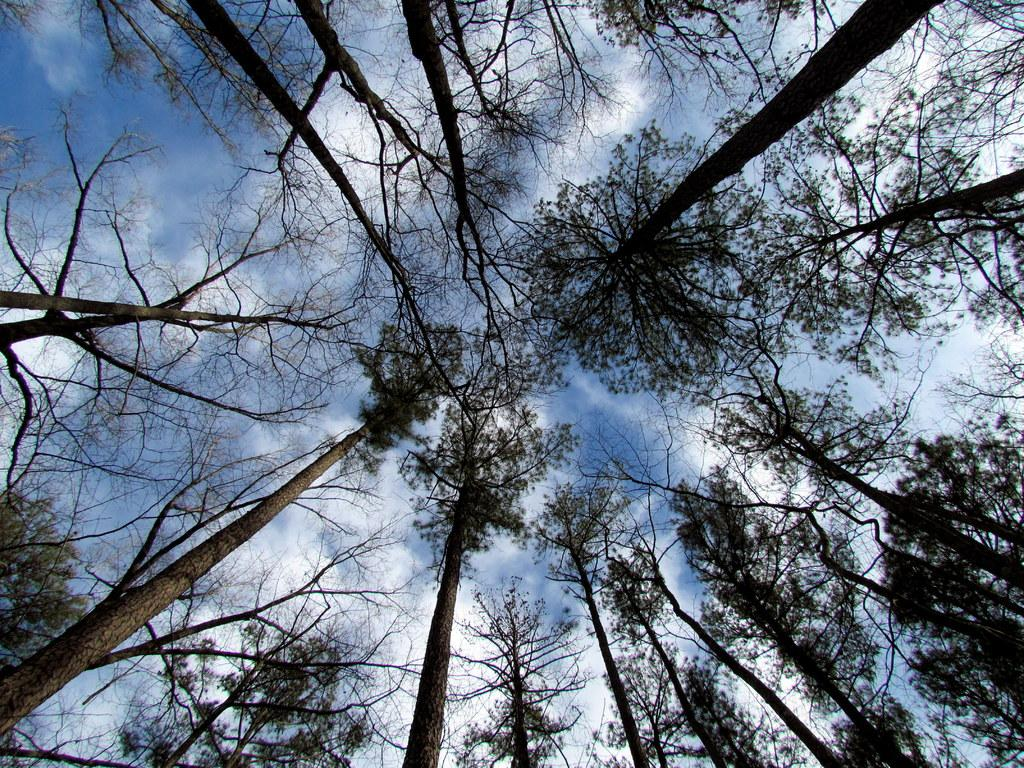Where was the image taken from? The image was taken from outside the city. What can be seen in the image besides the city? There are trees in the image. What is visible in the background of the image? The sky is visible in the background of the image. How would you describe the weather in the image? The sky is cloudy, which suggests a partly cloudy or overcast day. What is the rate of heat dissipation from the trees in the image? There is no information about heat dissipation or any specific temperature in the image, so it is not possible to determine the rate of heat dissipation from the trees. 